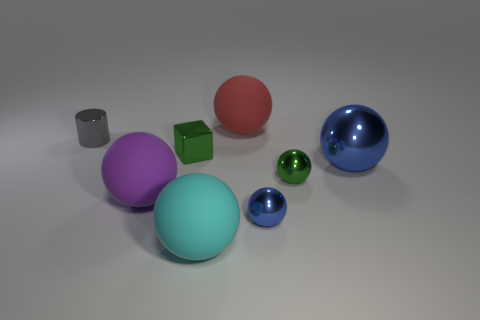Subtract all small spheres. How many spheres are left? 4 Subtract all red balls. How many balls are left? 5 Subtract all cylinders. How many objects are left? 7 Subtract all small metallic cylinders. Subtract all tiny metal cubes. How many objects are left? 6 Add 7 purple matte things. How many purple matte things are left? 8 Add 1 small purple spheres. How many small purple spheres exist? 1 Add 2 small green metallic spheres. How many objects exist? 10 Subtract 0 red cubes. How many objects are left? 8 Subtract 1 cylinders. How many cylinders are left? 0 Subtract all green cylinders. Subtract all green spheres. How many cylinders are left? 1 